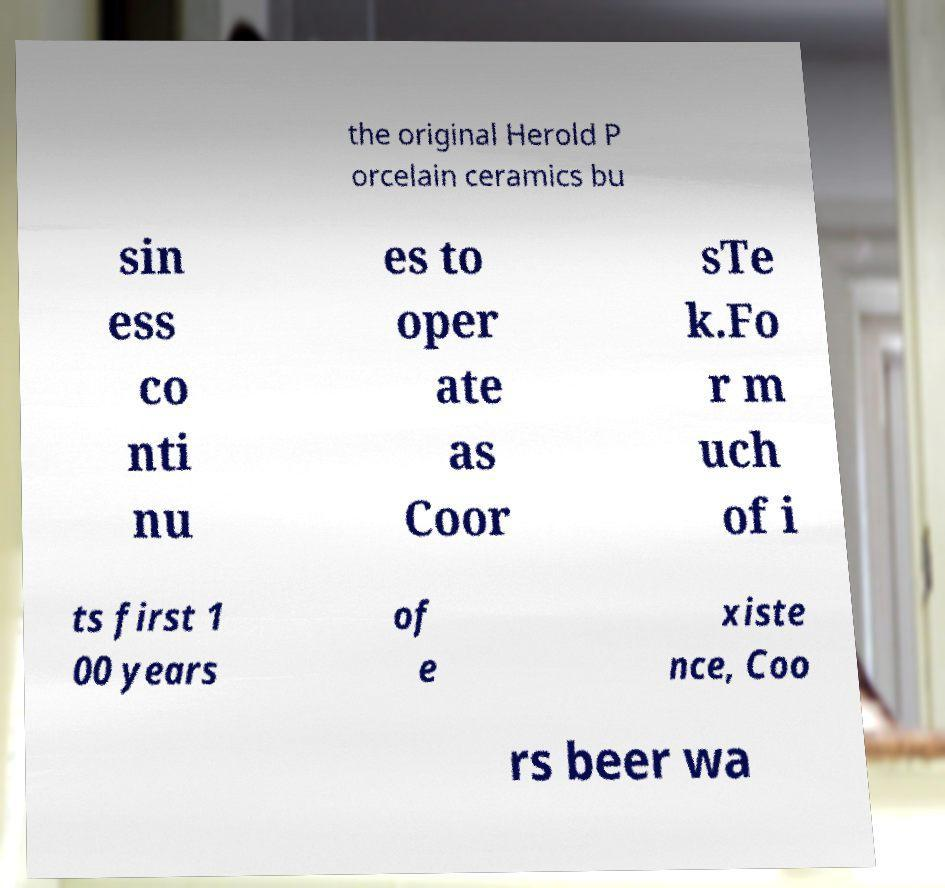Can you read and provide the text displayed in the image?This photo seems to have some interesting text. Can you extract and type it out for me? the original Herold P orcelain ceramics bu sin ess co nti nu es to oper ate as Coor sTe k.Fo r m uch of i ts first 1 00 years of e xiste nce, Coo rs beer wa 